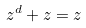Convert formula to latex. <formula><loc_0><loc_0><loc_500><loc_500>z ^ { d } + z = z</formula> 